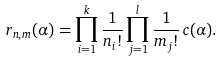Convert formula to latex. <formula><loc_0><loc_0><loc_500><loc_500>r _ { { n } , { m } } ( \alpha ) & = \prod _ { i = 1 } ^ { k } \frac { 1 } { n _ { i } ! } \prod _ { j = 1 } ^ { l } \frac { 1 } { m _ { j } ! } \, c ( \alpha ) .</formula> 